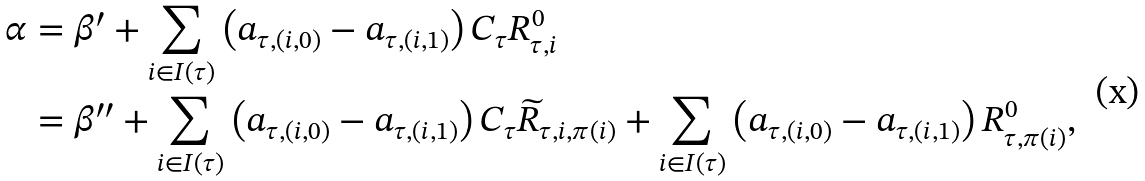Convert formula to latex. <formula><loc_0><loc_0><loc_500><loc_500>\alpha & = \beta ^ { \prime } + \sum _ { i \in I ( \tau ) } \left ( a _ { \tau , ( i , 0 ) } - a _ { \tau , ( i , 1 ) } \right ) C _ { \tau } R _ { \tau , i } ^ { 0 } \\ & = \beta ^ { \prime \prime } + \sum _ { i \in I ( \tau ) } \left ( a _ { \tau , ( i , 0 ) } - a _ { \tau , ( i , 1 ) } \right ) C _ { \tau } \widetilde { R } _ { \tau , i , \pi ( i ) } + \sum _ { i \in I ( \tau ) } \left ( a _ { \tau , ( i , 0 ) } - a _ { \tau , ( i , 1 ) } \right ) R _ { \tau , \pi ( i ) } ^ { 0 } ,</formula> 